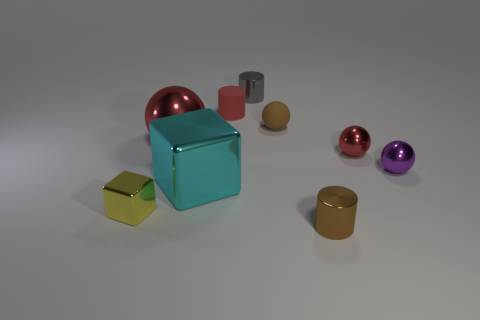Are there any other things that have the same color as the rubber cylinder?
Provide a succinct answer. Yes. There is a gray cylinder that is made of the same material as the tiny yellow thing; what size is it?
Your answer should be very brief. Small. The small brown object that is behind the small brown object that is to the right of the small brown object that is behind the small brown metal object is made of what material?
Provide a succinct answer. Rubber. Is the number of cyan rubber cubes less than the number of tiny metal cylinders?
Make the answer very short. Yes. Is the brown cylinder made of the same material as the purple thing?
Your answer should be compact. Yes. The small object that is the same color as the matte cylinder is what shape?
Offer a terse response. Sphere. There is a metal cylinder that is behind the red cylinder; is its color the same as the small rubber sphere?
Offer a terse response. No. There is a thing that is on the left side of the large sphere; how many purple things are in front of it?
Your response must be concise. 0. There is a ball that is the same size as the cyan metal cube; what color is it?
Give a very brief answer. Red. What material is the small sphere on the left side of the small brown metal object?
Make the answer very short. Rubber. 